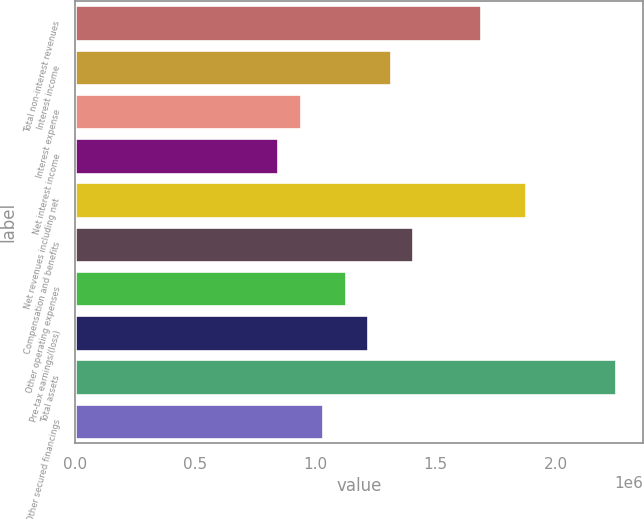<chart> <loc_0><loc_0><loc_500><loc_500><bar_chart><fcel>Total non-interest revenues<fcel>Interest income<fcel>Interest expense<fcel>Net interest income<fcel>Net revenues including net<fcel>Compensation and benefits<fcel>Other operating expenses<fcel>Pre-tax earnings/(loss)<fcel>Total assets<fcel>Other secured financings<nl><fcel>1.68939e+06<fcel>1.31397e+06<fcel>938555<fcel>844701<fcel>1.8771e+06<fcel>1.40783e+06<fcel>1.12626e+06<fcel>1.22012e+06<fcel>2.25251e+06<fcel>1.03241e+06<nl></chart> 